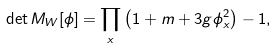<formula> <loc_0><loc_0><loc_500><loc_500>\det M _ { W } [ \phi ] = \prod _ { x } \left ( 1 + m + 3 g \phi _ { x } ^ { 2 } \right ) - 1 ,</formula> 